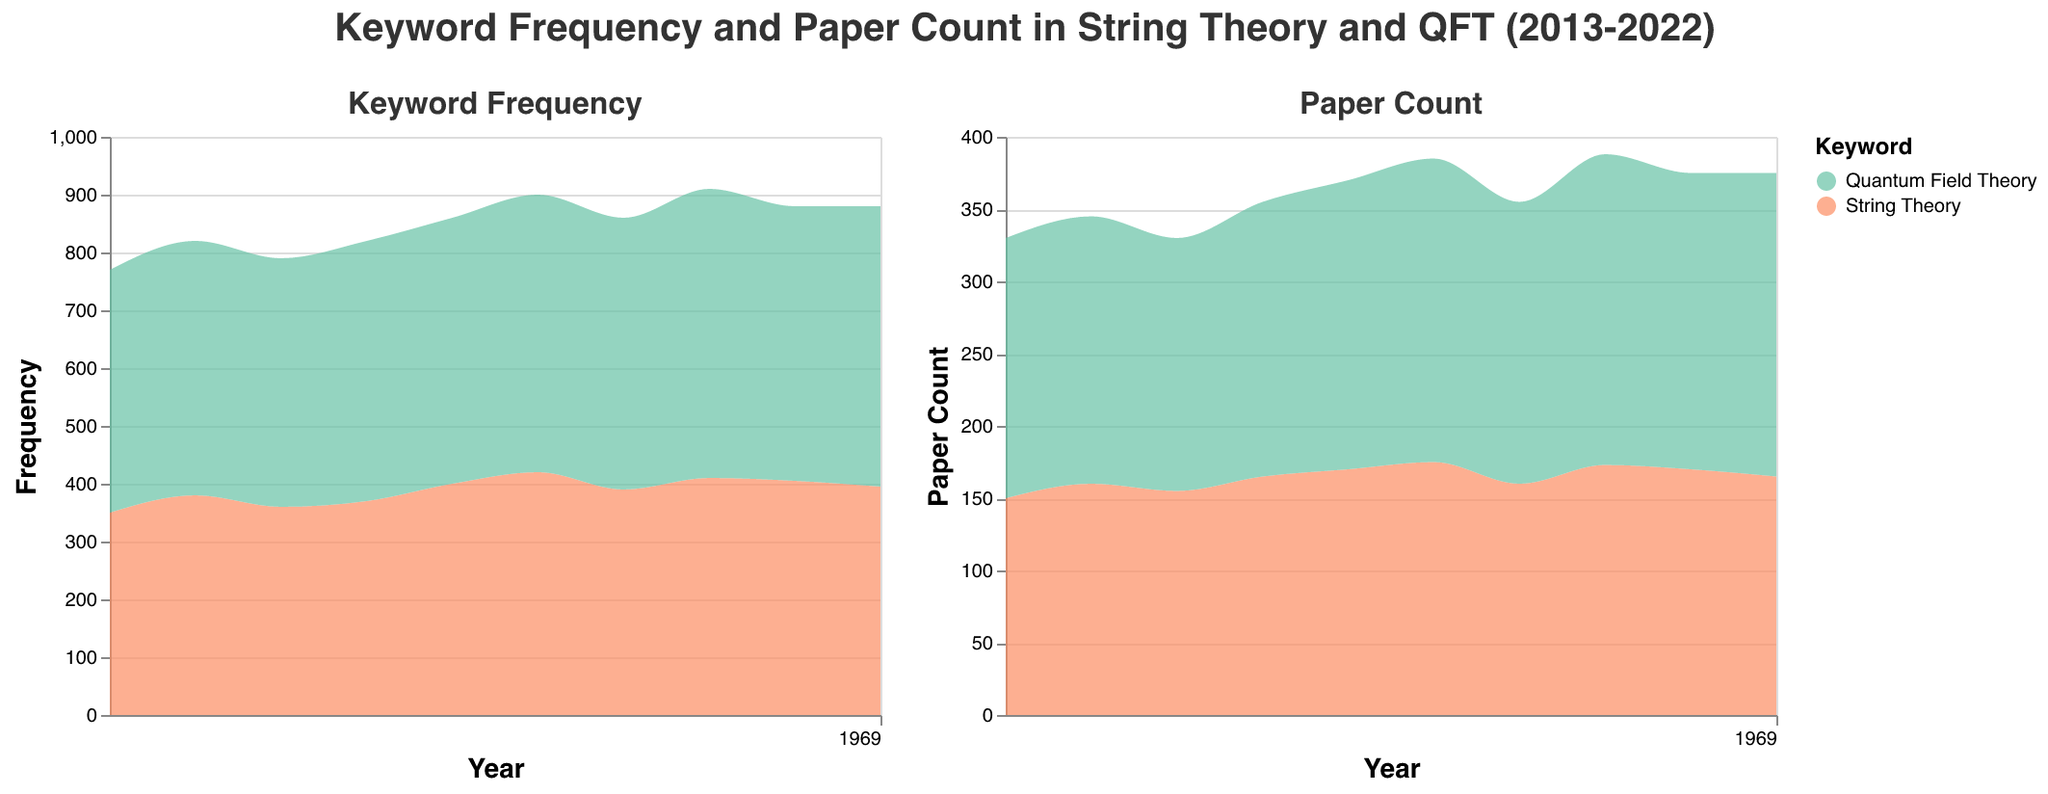what is the general trend of the keyword frequency for String Theory from 2013 to 2022? Examining the area plot on Keyword Frequency, the trend of keyword frequency for String Theory seems to show slight fluctuations but generally remains within the 350-420 range; it starts at 350 in 2013 and increases to 395 in 2022.
Answer: Slight fluctuations, no significant change How many years had Quantum Field Theory preceding String Theory in keyword frequency? By evaluating the area plot on Keyword Frequency, we see that Quantum Field Theory's frequency line is consistently higher than String Theory's line for each year between 2013 to 2022.
Answer: 10 years Which year had the maximum difference in paper count between Quantum Field Theory and String Theory? In the area plot for Paper Count, comparing the two lines reveals the maximum difference in 2020 where Quantum Field Theory had a count of 215 and String Theory had 173, resulting in a difference of 42 papers.
Answer: 2020 What was the overall trend observed for paper counts focusing on String Theory from 2013 to 2022? The area plot for Paper Count for String Theory shows a slight increase at first, dipping slightly in the middle years, and then generally stabilizing towards the end with minimal fluctuations around the 150-175 range.
Answer: Slight fluctuations, mainly stable In which year is the keyword frequency for Quantum Field Theory closest to 500? The area plot for Keyword Frequency shows that Quantum Field Theory hits exactly 500 in the year 2020.
Answer: 2020 Calculate the average keyword frequency for String Theory over the decade. We sum the yearly frequencies for String Theory and divide by the number of years: (350 + 380 + 360 + 370 + 400 + 420 + 390 + 410 + 405 + 395) / 10 = 1280 / 10 = 389.
Answer: 389 Which year shows the smallest difference between the keyword frequencies for String Theory and Quantum Field Theory? By observing the area plot, the year 2013 had the smallest difference; String Theory had 350 and Quantum Field Theory had 420, resulting in a difference of 70.
Answer: 2013 What pattern can be seen in the publication count for Quantum Field Theory papers from 2013 to 2022? Based on the area plot, the publication count for Quantum Field Theory papers exhibits a consistent upward trend from 2013 to 2022.
Answer: Consistent upward trend Is there any year where String Theory paper count was greater than Quantum Field Theory paper count? Reviewing the area plot for Paper Count, Quantum Field Theory's paper count is consistently higher than that for String Theory for each year throughout the dataset.
Answer: No, never 